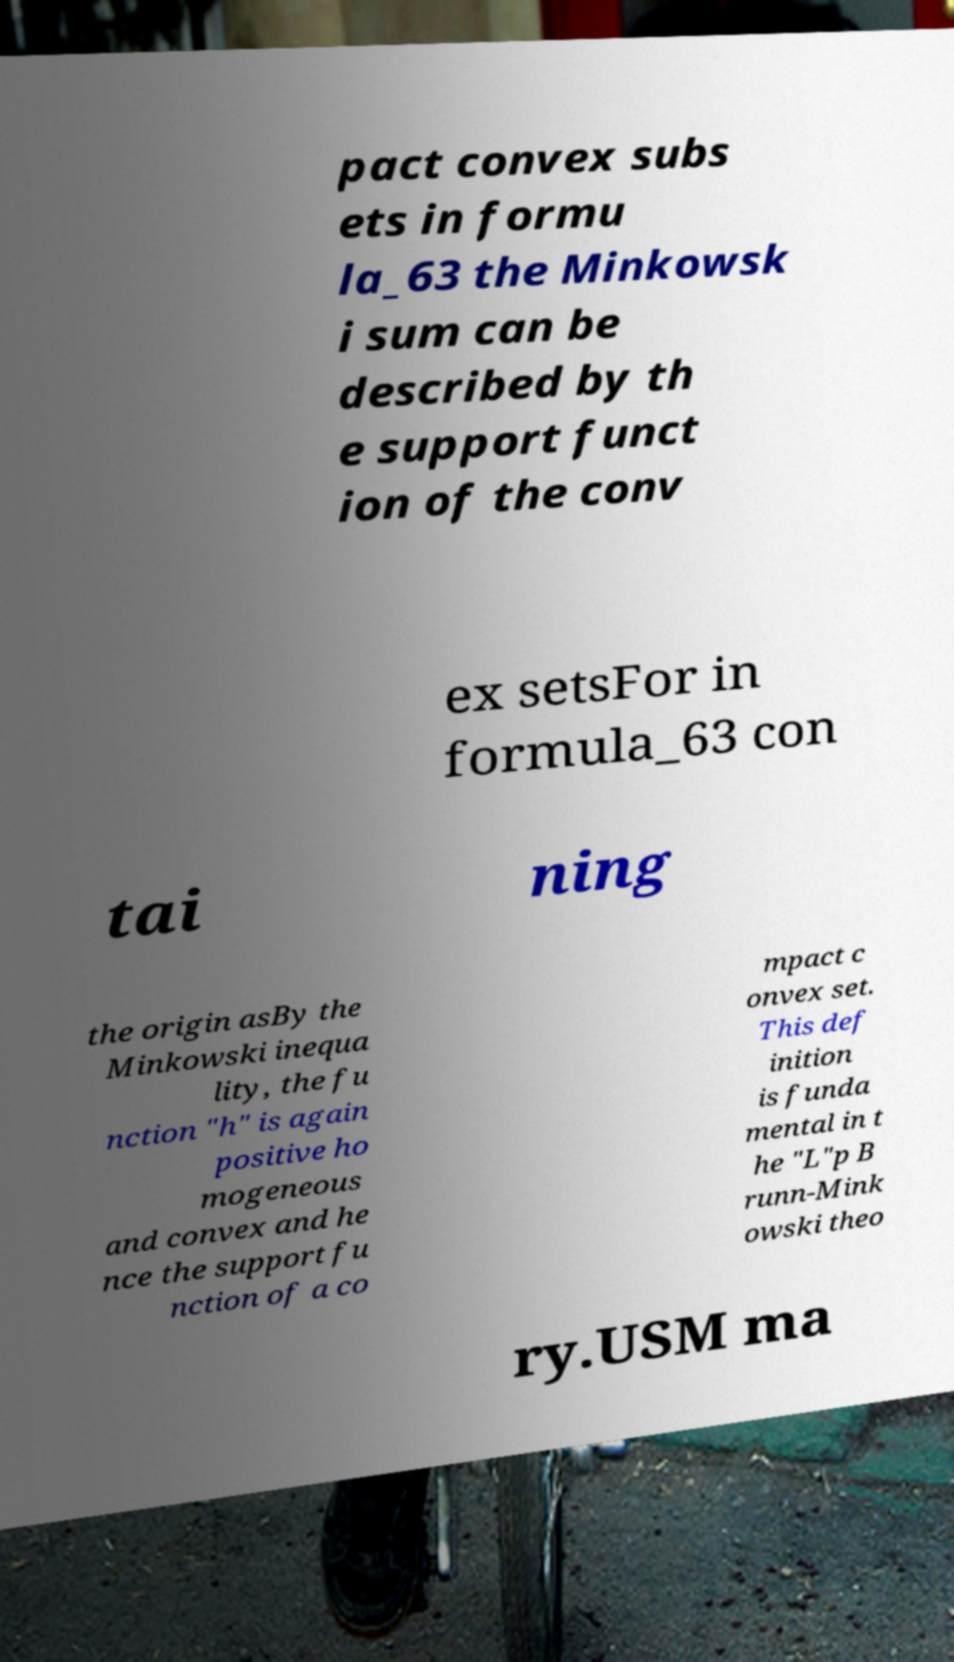Can you accurately transcribe the text from the provided image for me? pact convex subs ets in formu la_63 the Minkowsk i sum can be described by th e support funct ion of the conv ex setsFor in formula_63 con tai ning the origin asBy the Minkowski inequa lity, the fu nction "h" is again positive ho mogeneous and convex and he nce the support fu nction of a co mpact c onvex set. This def inition is funda mental in t he "L"p B runn-Mink owski theo ry.USM ma 